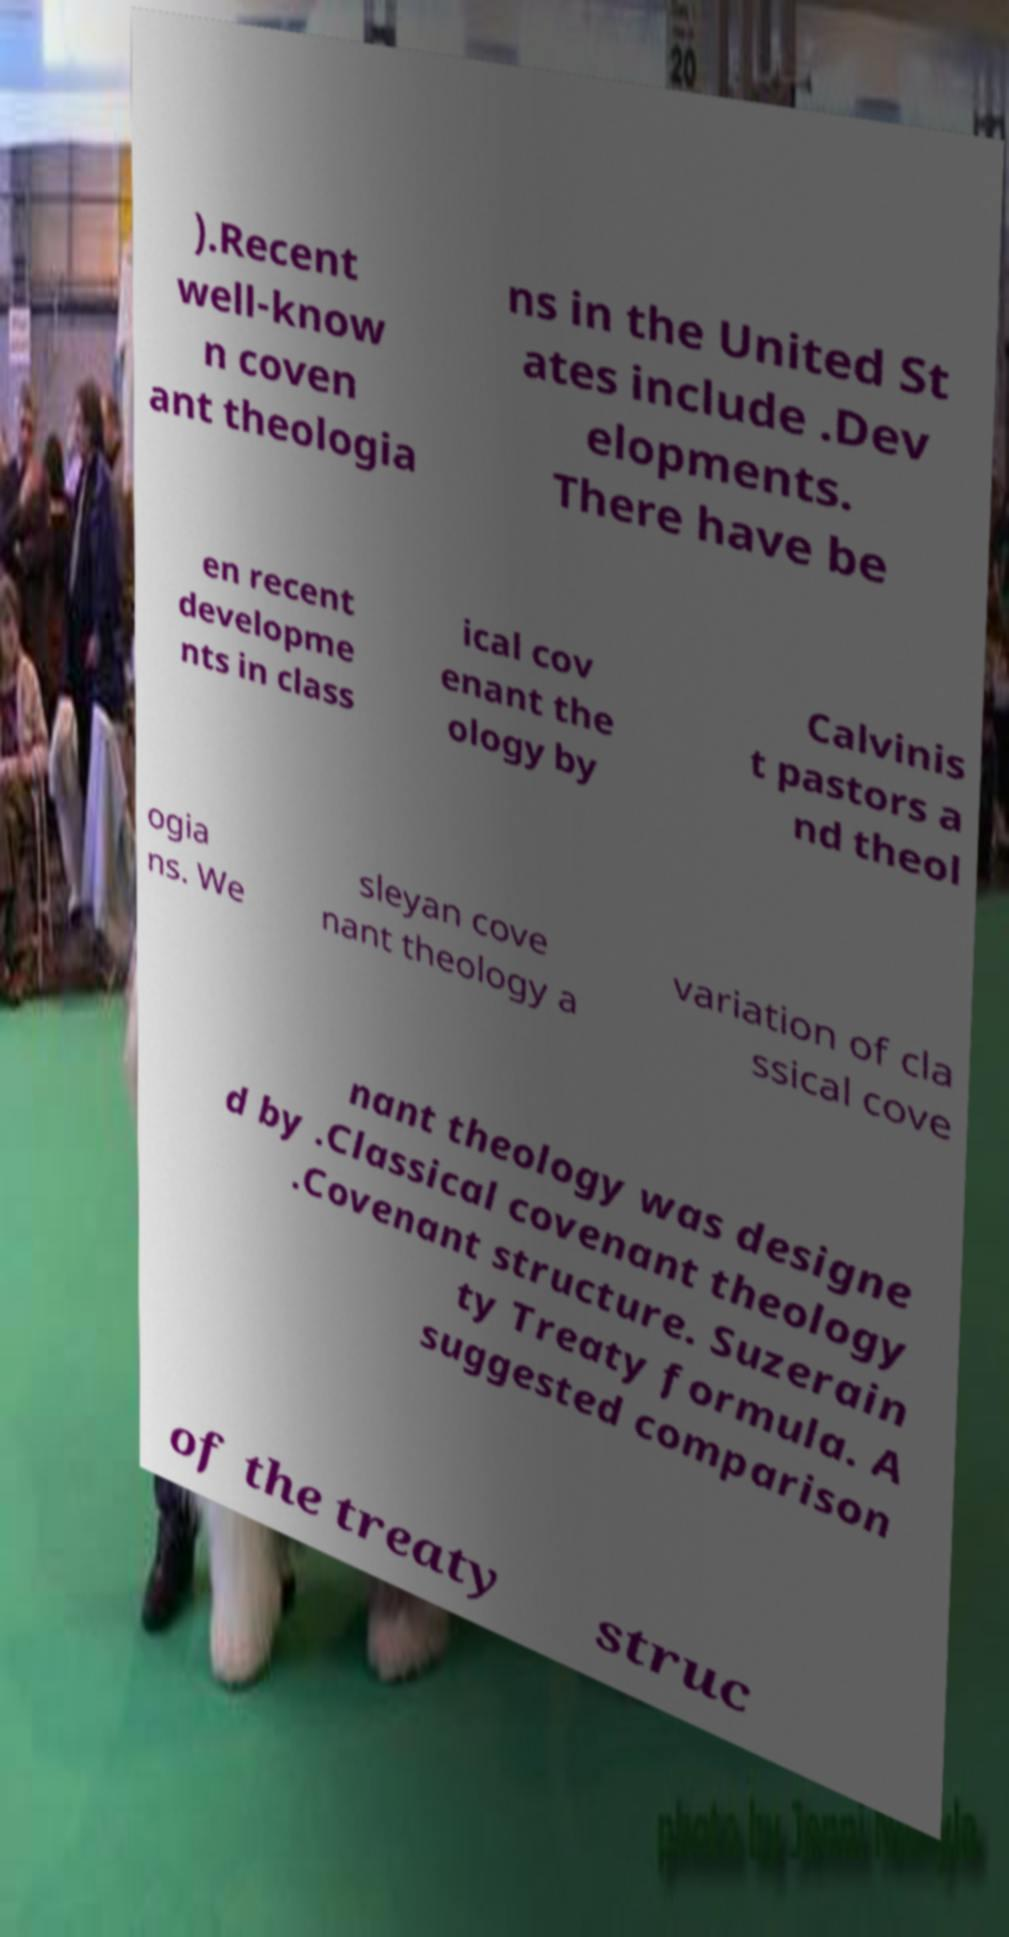Could you assist in decoding the text presented in this image and type it out clearly? ).Recent well-know n coven ant theologia ns in the United St ates include .Dev elopments. There have be en recent developme nts in class ical cov enant the ology by Calvinis t pastors a nd theol ogia ns. We sleyan cove nant theology a variation of cla ssical cove nant theology was designe d by .Classical covenant theology .Covenant structure. Suzerain ty Treaty formula. A suggested comparison of the treaty struc 